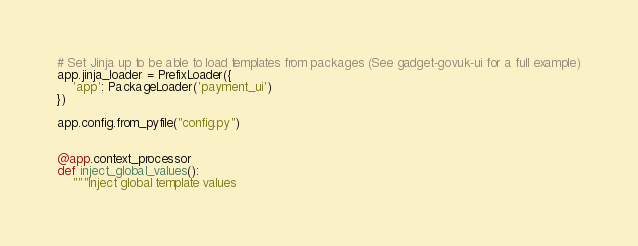Convert code to text. <code><loc_0><loc_0><loc_500><loc_500><_Python_># Set Jinja up to be able to load templates from packages (See gadget-govuk-ui for a full example)
app.jinja_loader = PrefixLoader({
    'app': PackageLoader('payment_ui')
})

app.config.from_pyfile("config.py")


@app.context_processor
def inject_global_values():
    """Inject global template values
</code> 